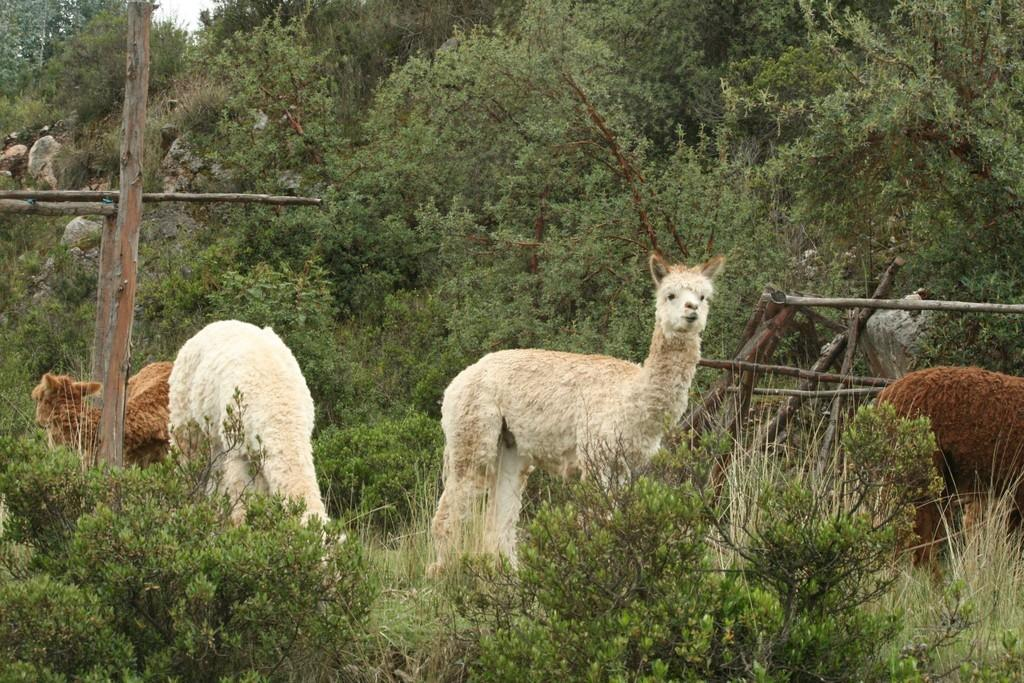What types of living organisms can be seen in the image? There are animals in the image. What type of natural features are present in the image? There are rocks, trees, and plants in the image. Can you describe any man-made objects in the image? Yes, there are objects in the image. What scent can be detected from the animals in the image? There is no information about the scent of the animals in the image, as smell is not a visual sense. 